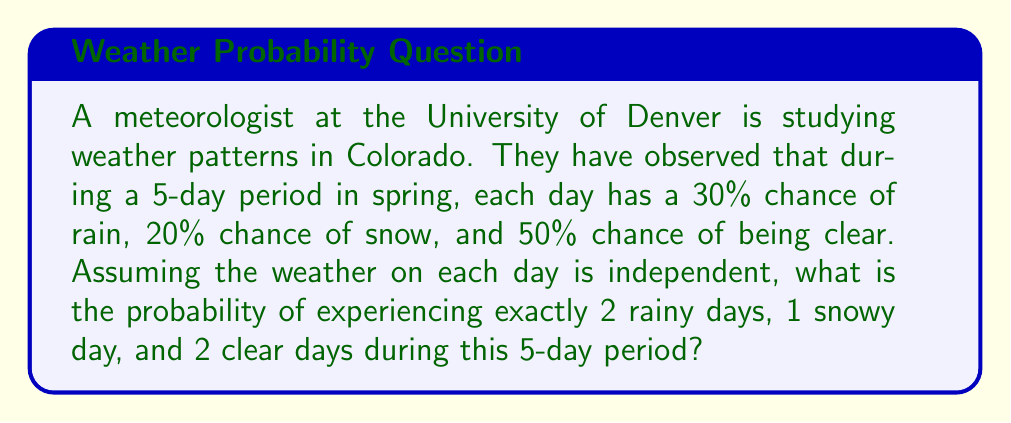Can you answer this question? To solve this problem, we'll use the multinomial probability formula:

$$P(X_1 = k_1, X_2 = k_2, ..., X_m = k_m) = \frac{n!}{k_1! k_2! ... k_m!} p_1^{k_1} p_2^{k_2} ... p_m^{k_m}$$

Where:
- $n$ is the total number of trials (days)
- $k_i$ is the number of occurrences of each outcome
- $p_i$ is the probability of each outcome

Given:
- $n = 5$ days
- $k_1 = 2$ (rainy days), $k_2 = 1$ (snowy day), $k_3 = 2$ (clear days)
- $p_1 = 0.30$ (probability of rain), $p_2 = 0.20$ (probability of snow), $p_3 = 0.50$ (probability of clear)

Step 1: Plug the values into the formula:

$$P(2 \text{ rain}, 1 \text{ snow}, 2 \text{ clear}) = \frac{5!}{2! 1! 2!} (0.30)^2 (0.20)^1 (0.50)^2$$

Step 2: Calculate the factorial terms:
$$\frac{5!}{2! 1! 2!} = \frac{5 \times 4 \times 3 \times 2 \times 1}{(2 \times 1)(1)(2 \times 1)} = 30$$

Step 3: Calculate the probability terms:
$$(0.30)^2 = 0.09$$
$$(0.20)^1 = 0.20$$
$$(0.50)^2 = 0.25$$

Step 4: Multiply all terms together:
$$30 \times 0.09 \times 0.20 \times 0.25 = 0.135$$

Therefore, the probability of experiencing exactly 2 rainy days, 1 snowy day, and 2 clear days during this 5-day period is 0.135 or 13.5%.
Answer: 0.135 